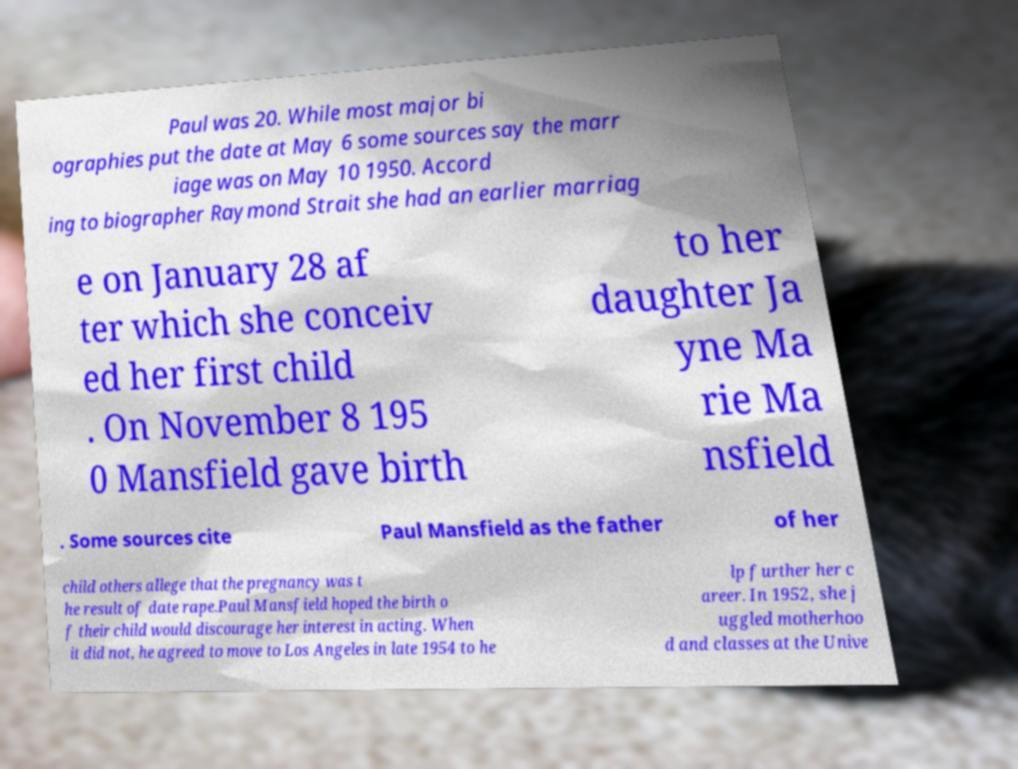There's text embedded in this image that I need extracted. Can you transcribe it verbatim? Paul was 20. While most major bi ographies put the date at May 6 some sources say the marr iage was on May 10 1950. Accord ing to biographer Raymond Strait she had an earlier marriag e on January 28 af ter which she conceiv ed her first child . On November 8 195 0 Mansfield gave birth to her daughter Ja yne Ma rie Ma nsfield . Some sources cite Paul Mansfield as the father of her child others allege that the pregnancy was t he result of date rape.Paul Mansfield hoped the birth o f their child would discourage her interest in acting. When it did not, he agreed to move to Los Angeles in late 1954 to he lp further her c areer. In 1952, she j uggled motherhoo d and classes at the Unive 